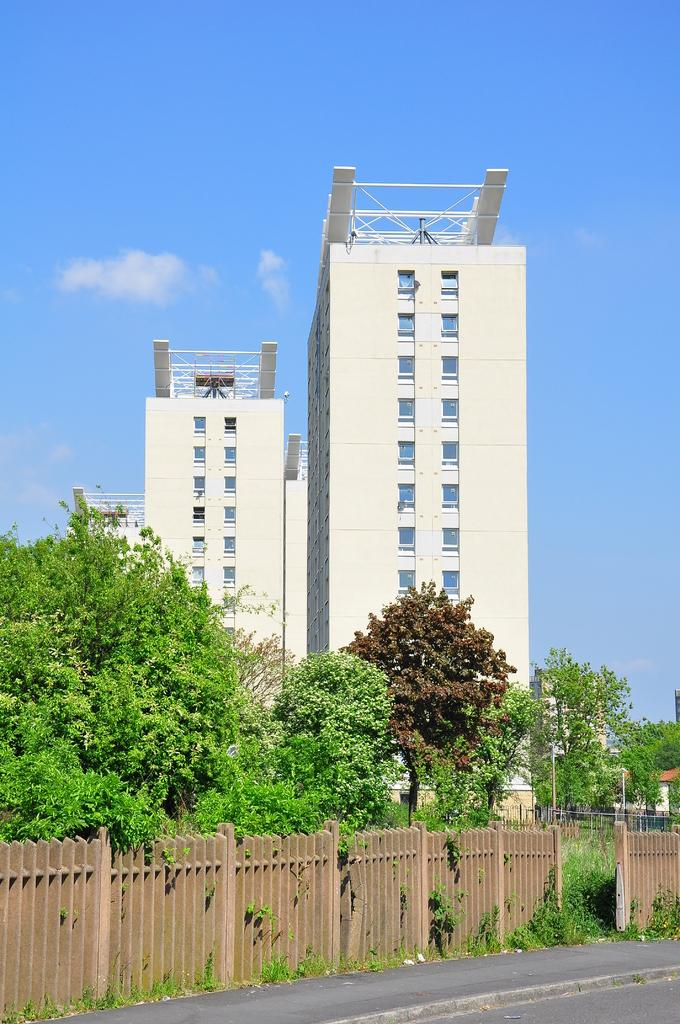What is the main feature of the image? There is a road in the image. What can be seen alongside the road? There is a wooden fence in the image. What is visible in the background of the image? There are trees, light poles, buildings, and the sky visible in the background of the image. What type of song is being played by the metal invention in the image? There is no song or metal invention present in the image. 